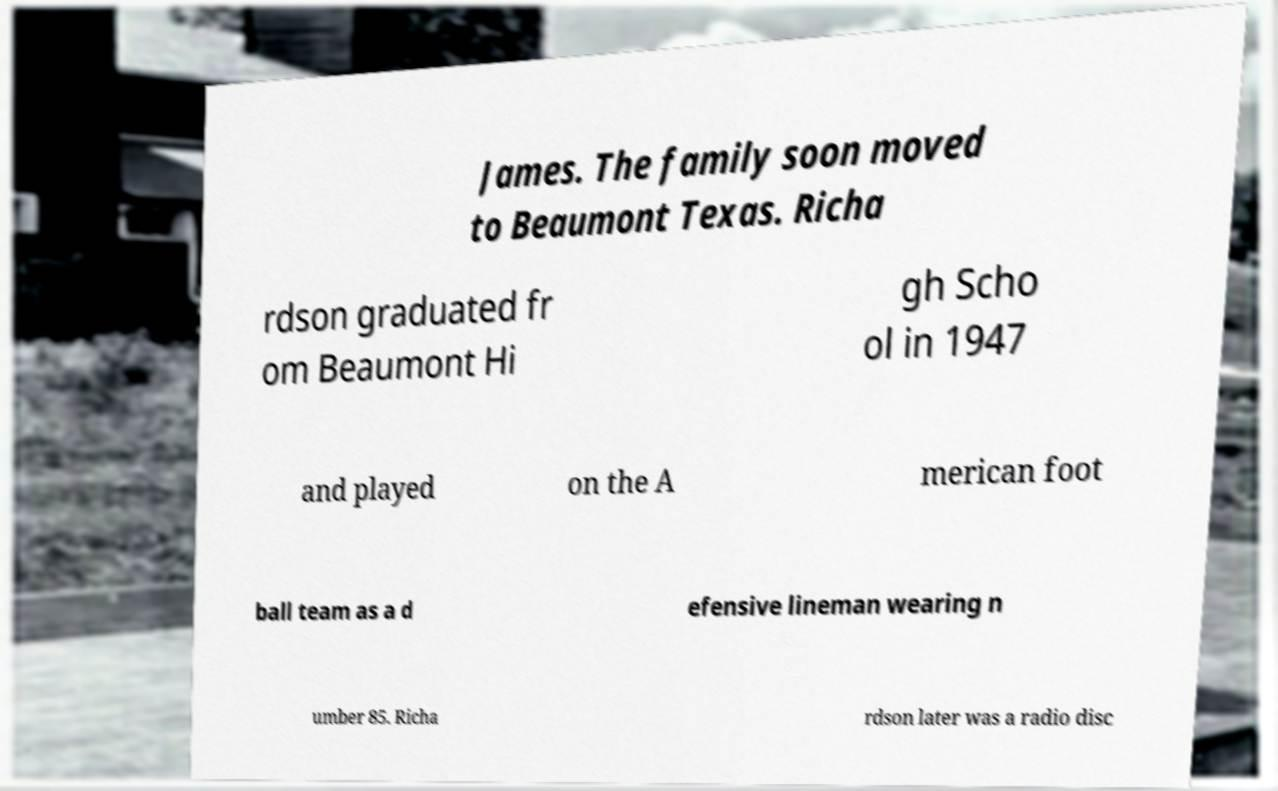Can you accurately transcribe the text from the provided image for me? James. The family soon moved to Beaumont Texas. Richa rdson graduated fr om Beaumont Hi gh Scho ol in 1947 and played on the A merican foot ball team as a d efensive lineman wearing n umber 85. Richa rdson later was a radio disc 